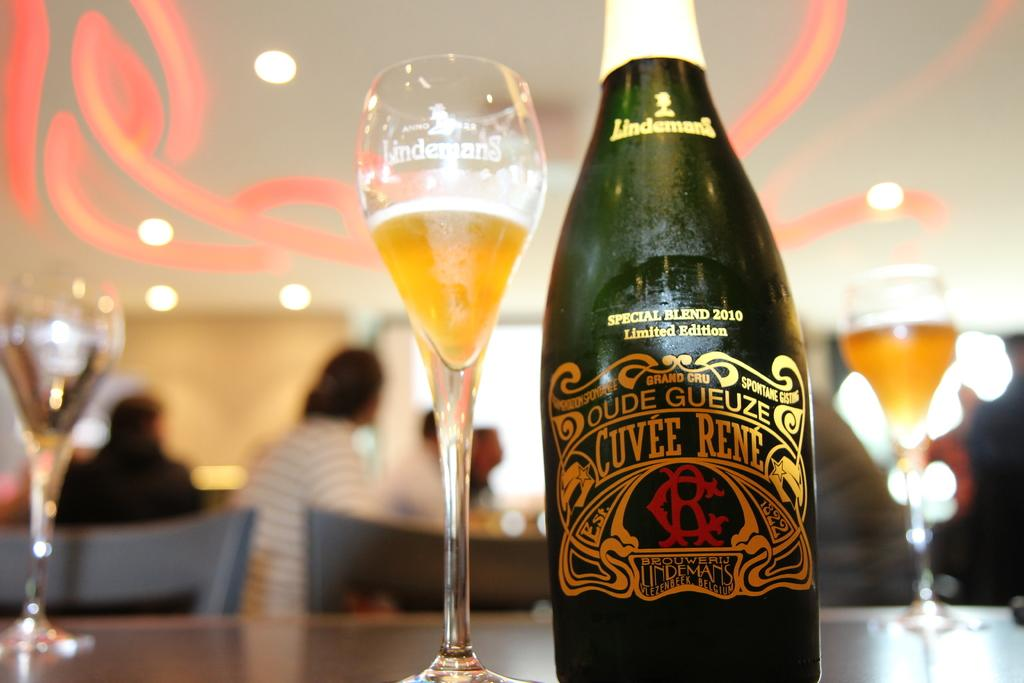Provide a one-sentence caption for the provided image. A bottle of oude gueze next to glasses with liquid in there. 